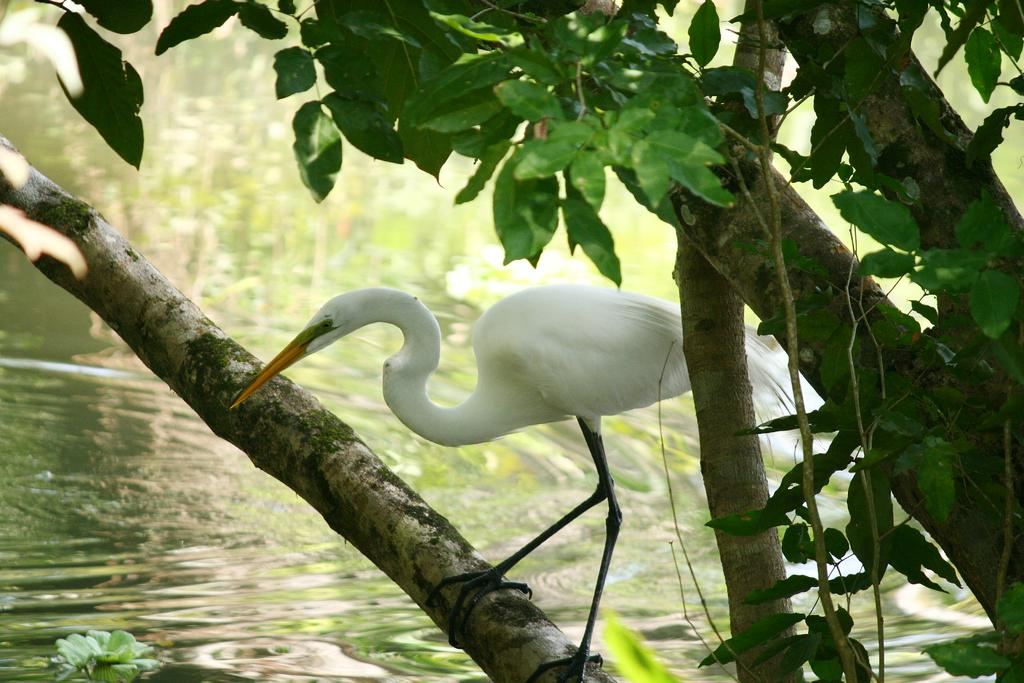What type of animal is on the tree in the image? There is a crane on a tree in the image. What can be seen in the background of the image? Water is visible in the image. What type of apparel is the crane wearing in the image? The crane is a bird and does not wear apparel. How is the oatmeal being prepared in the image? There is no oatmeal present in the image. 